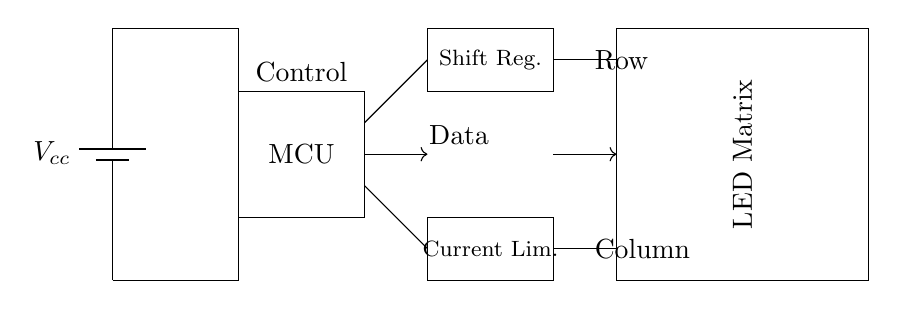What is the main power supply voltage in the circuit? The voltage is labeled as Vcc, which typically indicates the main power supply voltage for the circuit. While the exact value isn't provided, it is commonly 3 to 5 volts for LED circuits.
Answer: Vcc What component controls the LED matrix? The microcontroller (MCU) is responsible for controlling the LED matrix, as it interfaces to send data to the shift register, which then controls the LEDs.
Answer: MCU What component is used for data shifting in this circuit? The shift register is indicated in the diagram as responsible for data shifting, transitioning signals from the microcontroller to control the rows of the LED matrix.
Answer: Shift Reg How many components are in series between the power supply and the LED matrix? There are two components in series: the microcontroller and the shift register stand between the power supply and the LED matrix, forming a chain that distributes power and control signals.
Answer: Two What is the function of the current limiter in the circuit? The current limiter ensures that the current flowing to the LED matrix is controlled, preventing damage to the LEDs by keeping the current within safe limits according to their specifications.
Answer: Current control What does the arrow represent in this circuit? The arrows in the diagram indicate the direction of data flow between the components, showing how data is transmitted from the microcontroller to the shift register and then to the LED matrix.
Answer: Data flow What type of display does the circuit drive? The diagram indicates that the circuit drives an LED matrix, which is composed of multiple light-emitting diodes arranged in a matrix format to create visual displays in handheld devices.
Answer: LED Matrix 